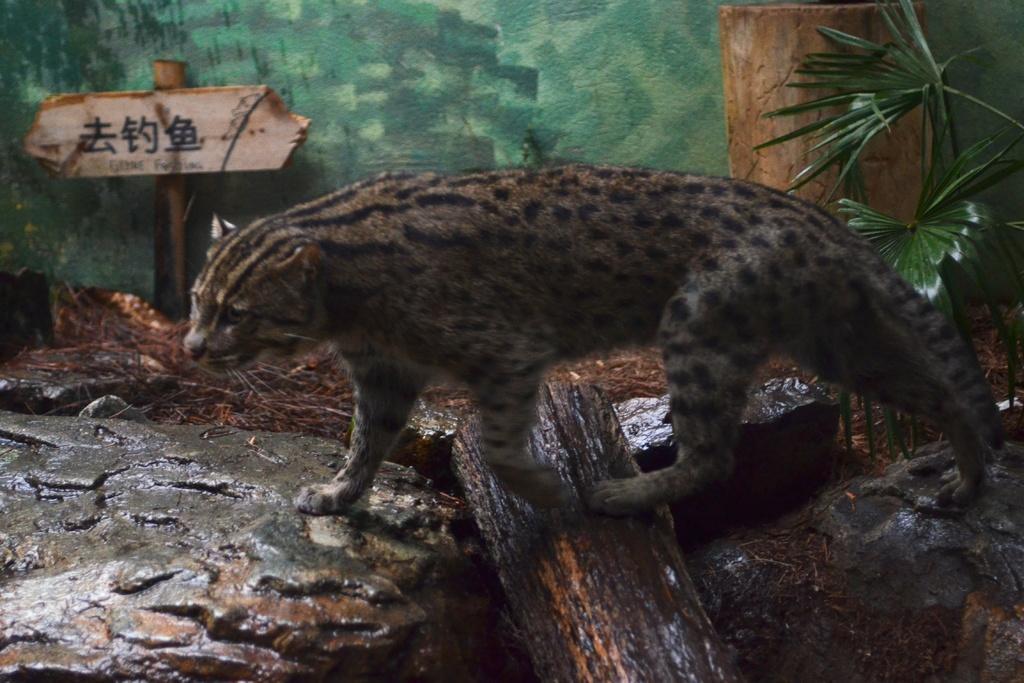Can you describe this image briefly? In the center of the image there is a animal. At the bottom of the image there is a tree trunk. At the background of the image there is a wall and there is a sign board. 